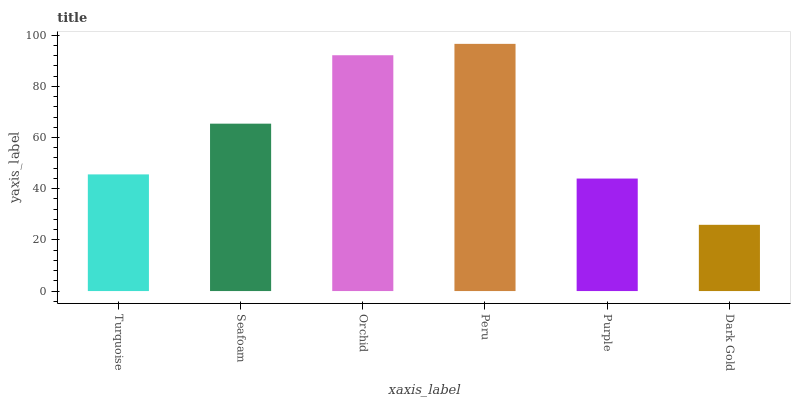Is Dark Gold the minimum?
Answer yes or no. Yes. Is Peru the maximum?
Answer yes or no. Yes. Is Seafoam the minimum?
Answer yes or no. No. Is Seafoam the maximum?
Answer yes or no. No. Is Seafoam greater than Turquoise?
Answer yes or no. Yes. Is Turquoise less than Seafoam?
Answer yes or no. Yes. Is Turquoise greater than Seafoam?
Answer yes or no. No. Is Seafoam less than Turquoise?
Answer yes or no. No. Is Seafoam the high median?
Answer yes or no. Yes. Is Turquoise the low median?
Answer yes or no. Yes. Is Dark Gold the high median?
Answer yes or no. No. Is Peru the low median?
Answer yes or no. No. 